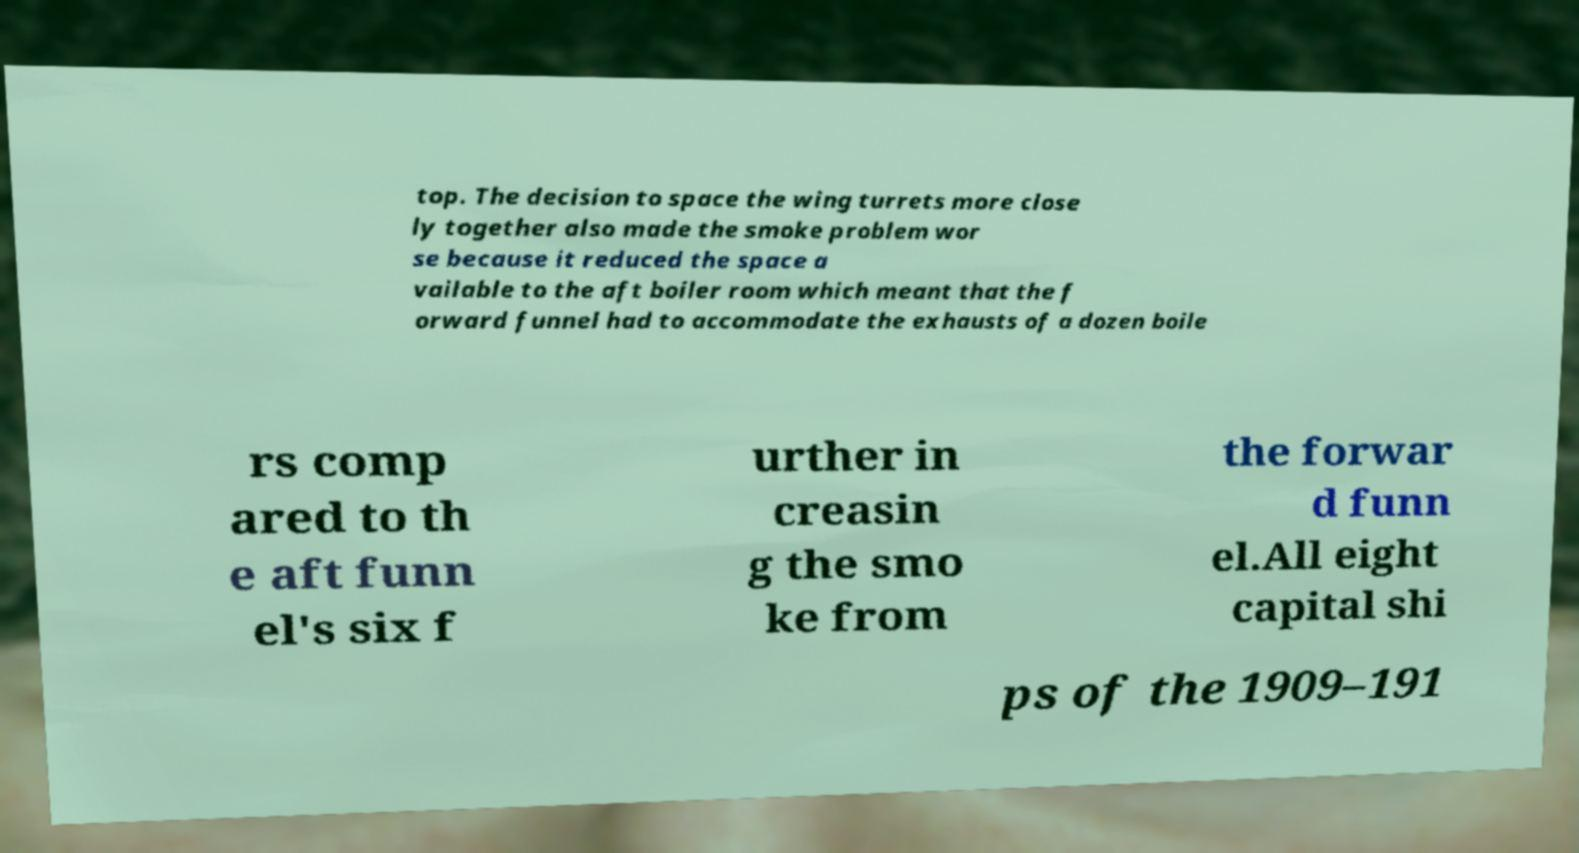Can you accurately transcribe the text from the provided image for me? top. The decision to space the wing turrets more close ly together also made the smoke problem wor se because it reduced the space a vailable to the aft boiler room which meant that the f orward funnel had to accommodate the exhausts of a dozen boile rs comp ared to th e aft funn el's six f urther in creasin g the smo ke from the forwar d funn el.All eight capital shi ps of the 1909–191 